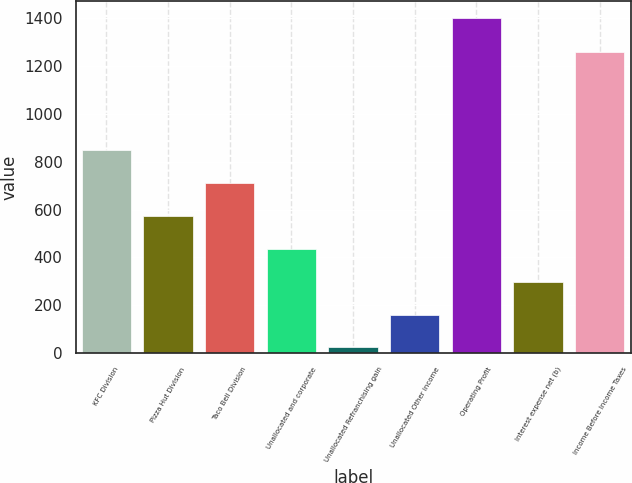Convert chart to OTSL. <chart><loc_0><loc_0><loc_500><loc_500><bar_chart><fcel>KFC Division<fcel>Pizza Hut Division<fcel>Taco Bell Division<fcel>Unallocated and corporate<fcel>Unallocated Refranchising gain<fcel>Unallocated Other income<fcel>Operating Profit<fcel>Interest expense net (b)<fcel>Income Before Income Taxes<nl><fcel>850.4<fcel>574.6<fcel>712.5<fcel>436.7<fcel>23<fcel>160.9<fcel>1402<fcel>298.8<fcel>1261<nl></chart> 